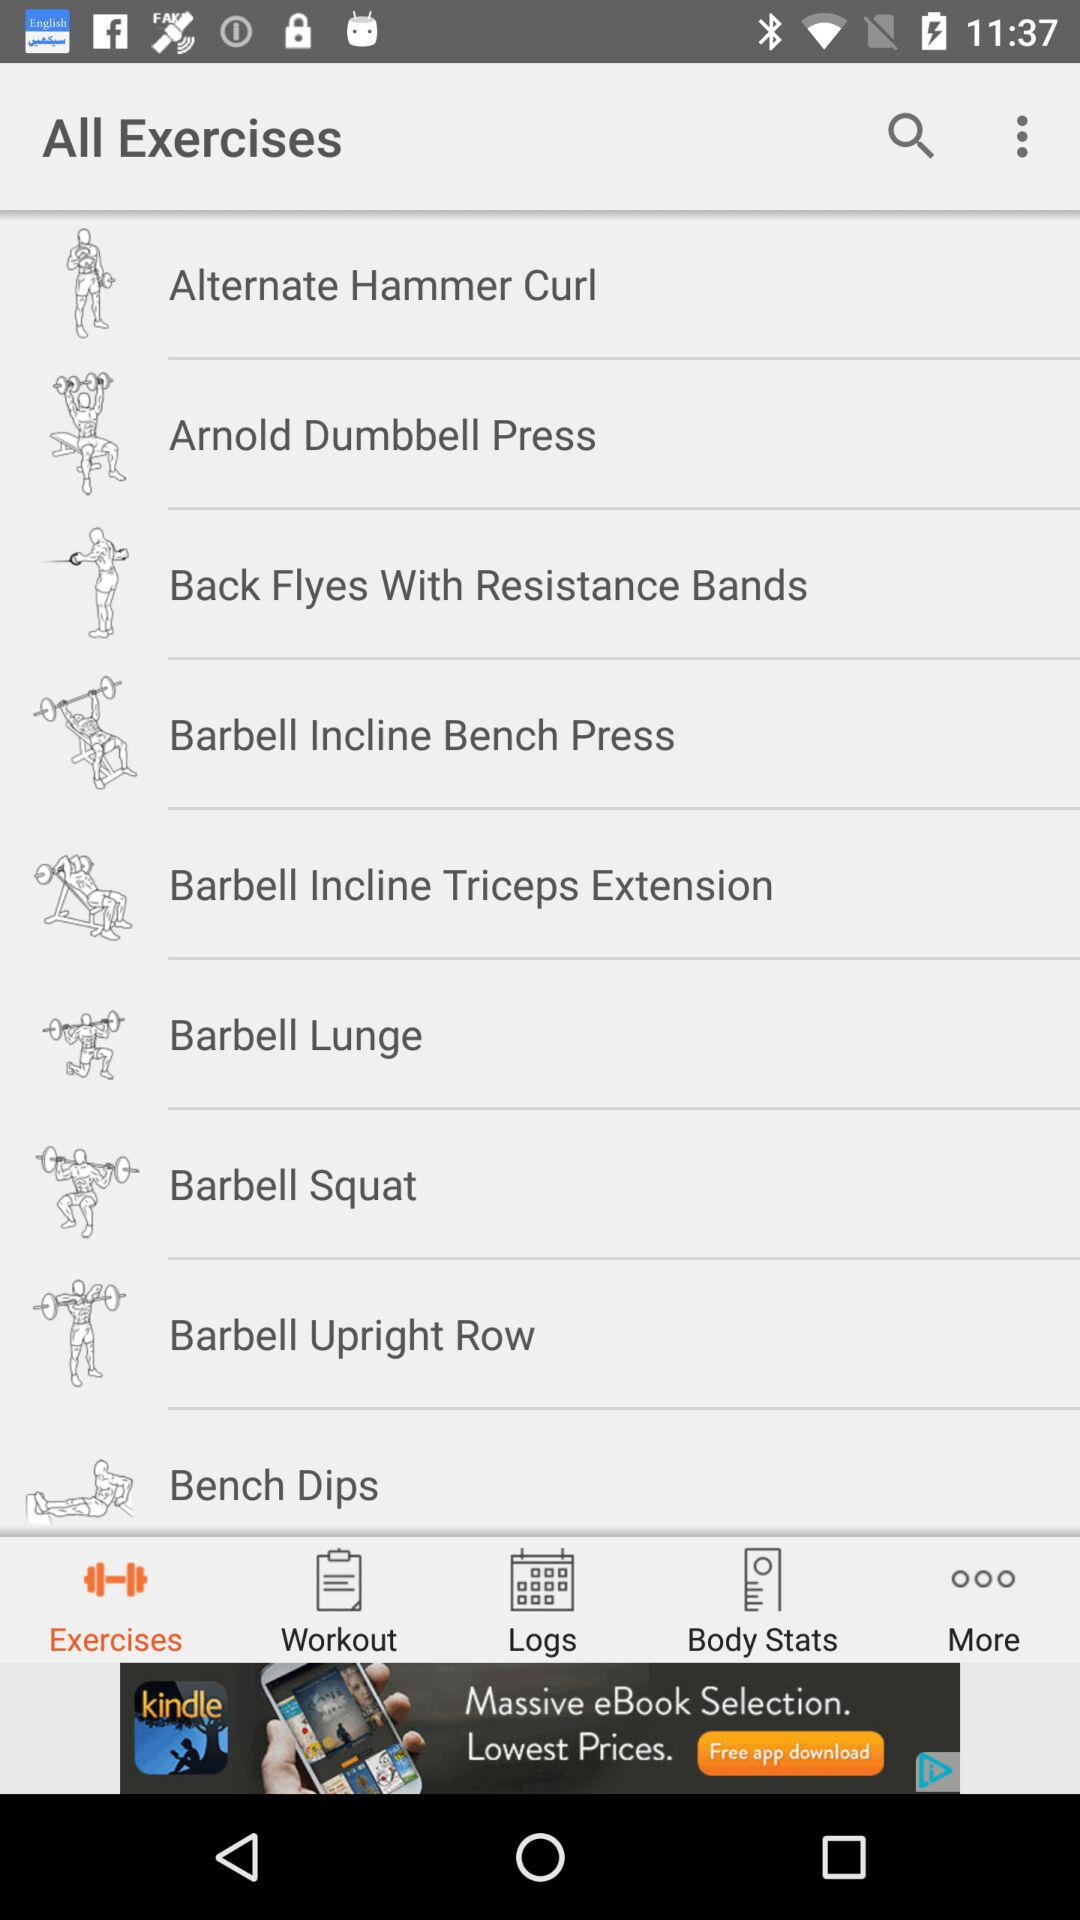What are the names of the different exercises? The names of the different exercises are "Alternate Hammer Curl", "Arnold Dumbbell Press", "Back Flyes With Resistance Bands", "Barbell Incline Bench Press", "Barbell Incline Triceps Extension", "Barbell Lunge", "Barbell Squat", "Barbell Upright Row" and "Bench Dips". 